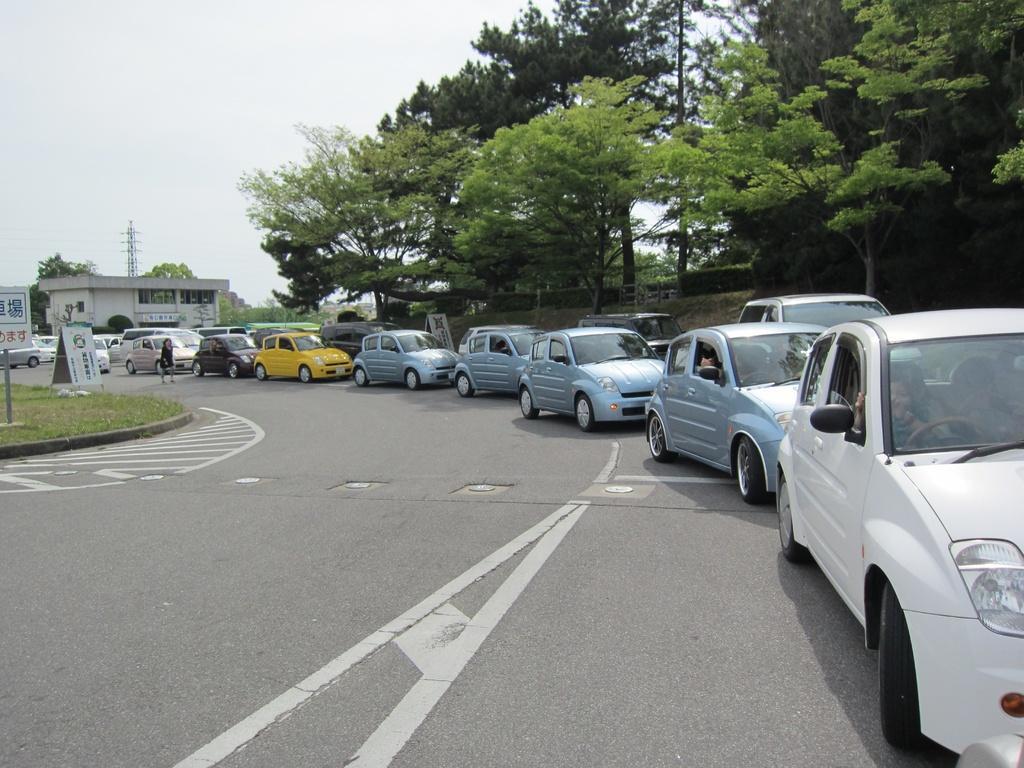Could you give a brief overview of what you see in this image? In the center of the image there is road. There are vehicles parked on the road. To the right side of the image there are trees. At the top of the image there is sky. In the background of the image there is house. To the left side of the image there is grass. 